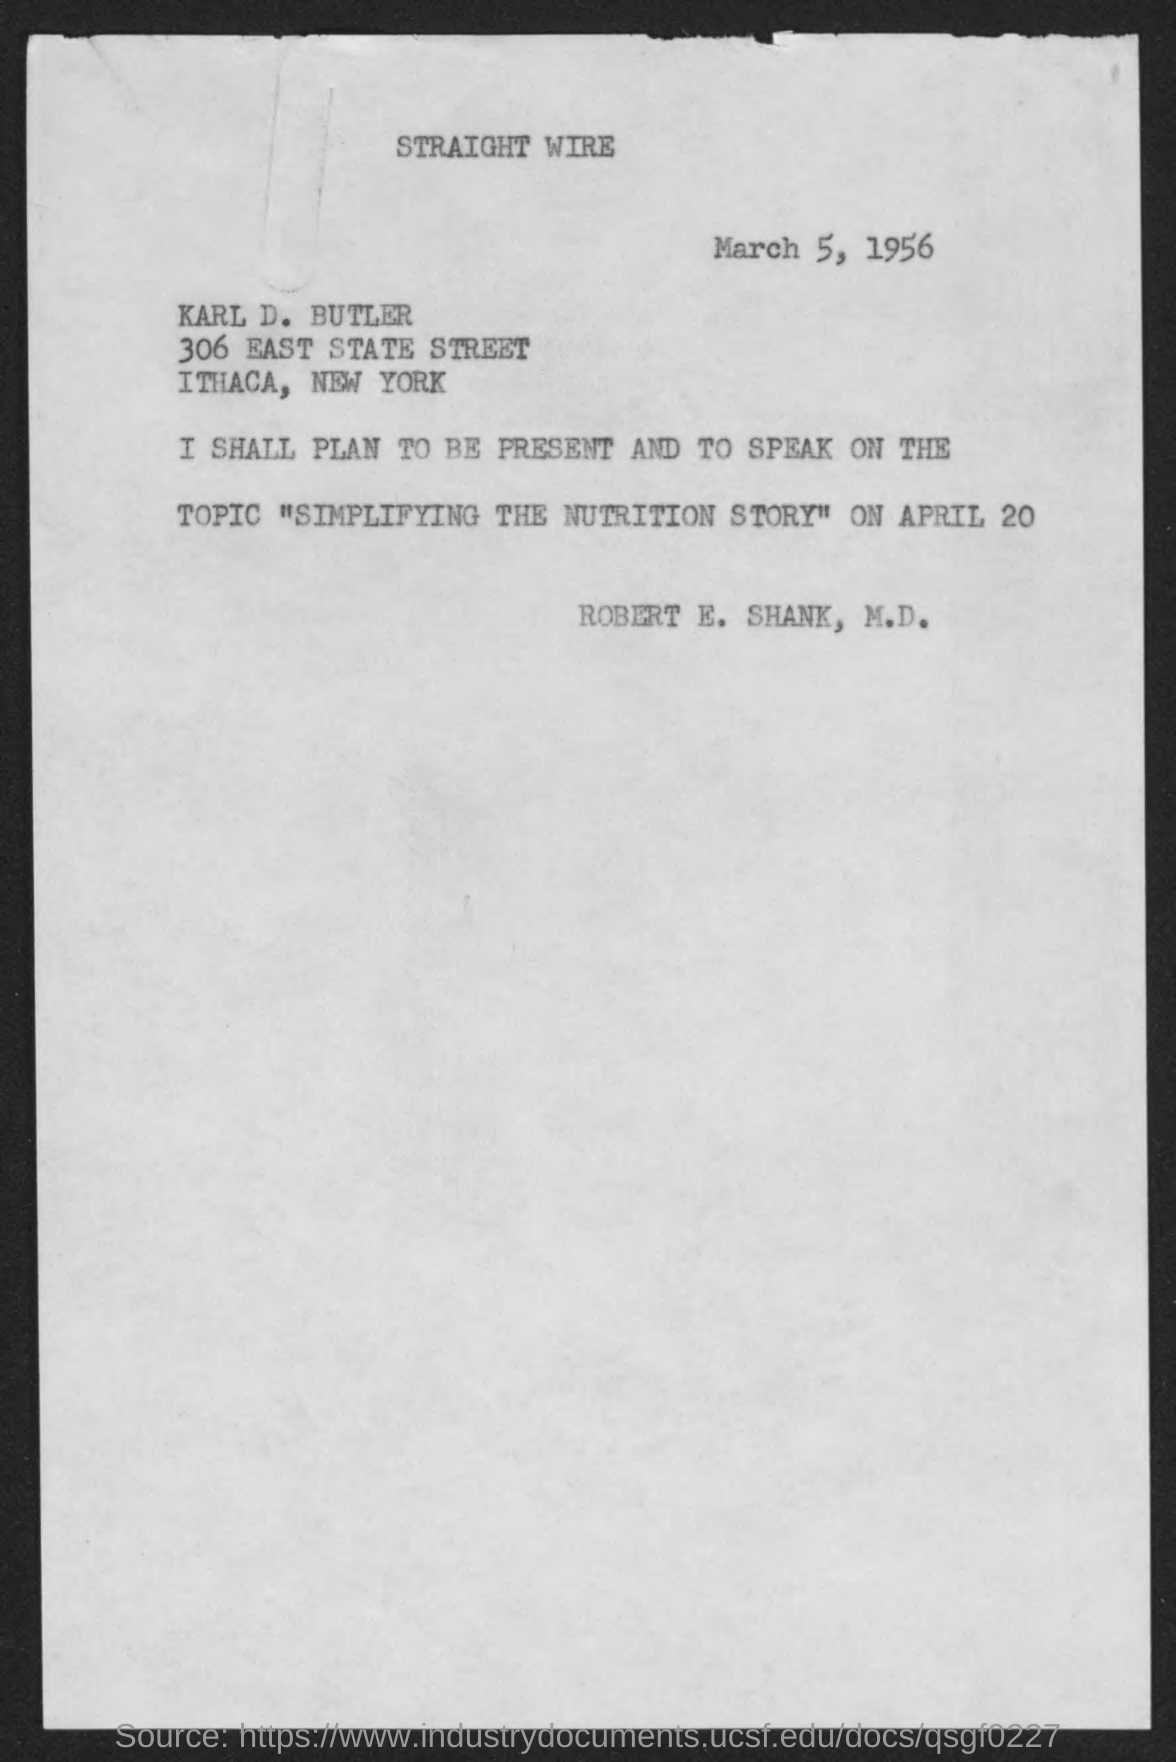What is the date mentioned in the given page ?
Keep it short and to the point. March 5, 1956. What is the topic name mentioned in the given letter ?
Give a very brief answer. "simplifying the nutrition story". On which date he has to present and speak on the given topic ?
Offer a terse response. April 20. 